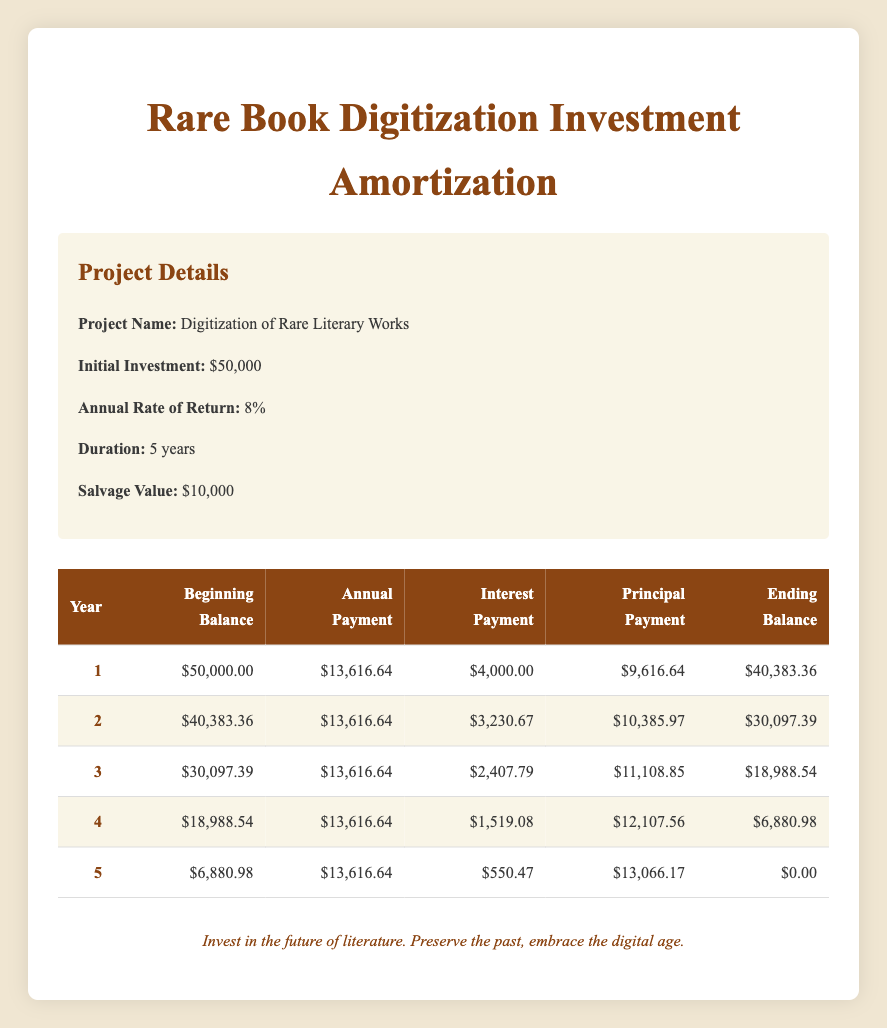What was the total annual payment made in the first year? The annual payment made in the first year is listed directly in the table under the annual payment column for year 1, which is $13,616.64.
Answer: 13,616.64 What is the interest payment in the third year? The interest payment for year 3 is noted in the table under the interest payment column for that year, which is $2,407.79.
Answer: 2,407.79 In which year did the principal payment exceed $12,000? Looking through the principal payment column, it can be observed that the principal payment exceeds $12,000 in year 4, where it is $12,107.56.
Answer: Year 4 What is the total interest paid over the five years? To find the total interest, sum the interest payments from each year: ($4,000 + $3,230.67 + $2,407.79 + $1,519.08 + $550.47) = $11,707.01.
Answer: 11,707.01 Is the ending balance in year 2 greater than the salvage value of $10,000? The ending balance in year 2 is $30,097.39, which is greater than the salvage value of $10,000. Thus, the statement is true.
Answer: Yes What was the change in beginning balance from year 1 to year 2? The beginning balance in year 1 is $50,000 and in year 2 it is $40,383.36. The change is calculated by subtracting the second year's beginning balance from the first: $50,000 - $40,383.36 = $9,616.64.
Answer: 9,616.64 How much principal was paid down by year 5 compared to year 1? The principal payment in year 1 is $9,616.64, and in year 5 it is $13,066.17. The increase in principal payment is calculated as $13,066.17 - $9,616.64 = $3,449.53.
Answer: 3,449.53 What is the average annual payment over the duration of the investment? The average annual payment is calculated by summing all the annual payments ($13,616.64 x 5 years = $68,083.20) and then dividing by 5, yielding an average payment of $13,616.64.
Answer: 13,616.64 